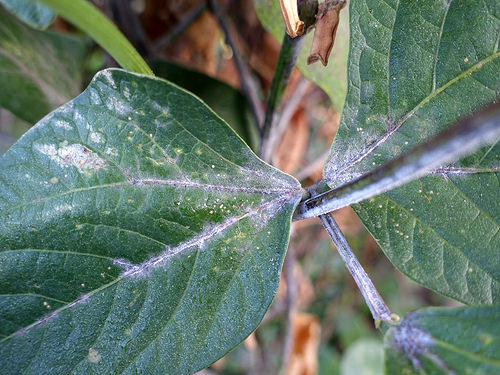<image>
Is there a mold on the leaf? No. The mold is not positioned on the leaf. They may be near each other, but the mold is not supported by or resting on top of the leaf. 